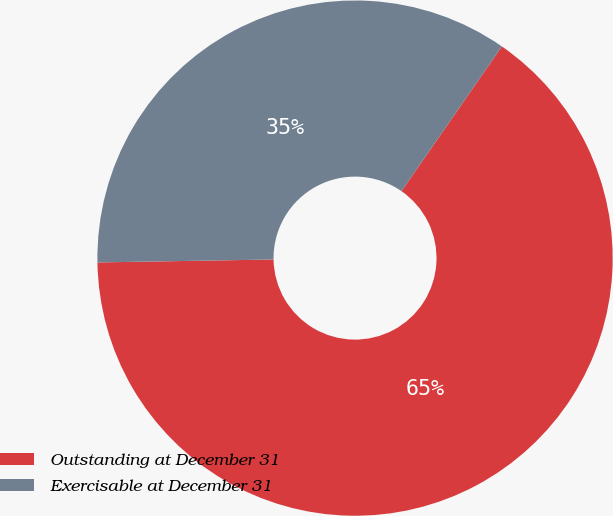Convert chart. <chart><loc_0><loc_0><loc_500><loc_500><pie_chart><fcel>Outstanding at December 31<fcel>Exercisable at December 31<nl><fcel>65.08%<fcel>34.92%<nl></chart> 